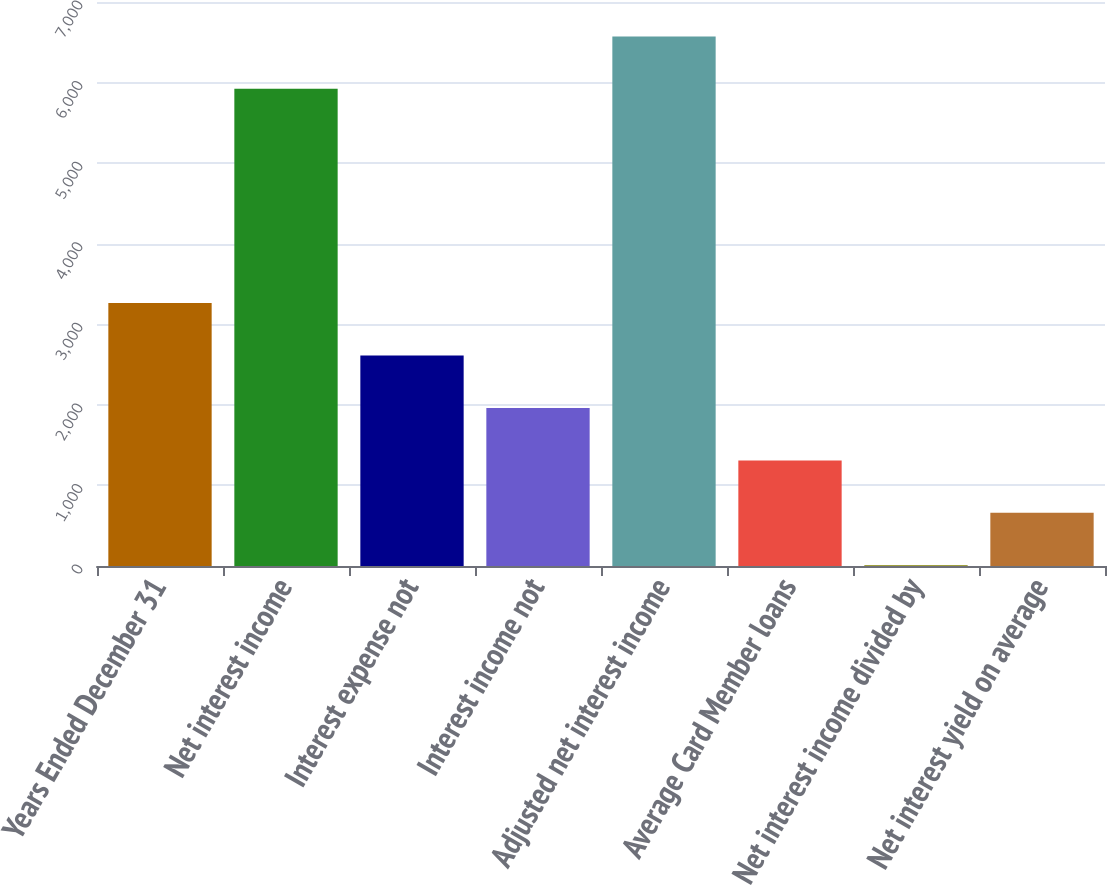<chart> <loc_0><loc_0><loc_500><loc_500><bar_chart><fcel>Years Ended December 31<fcel>Net interest income<fcel>Interest expense not<fcel>Interest income not<fcel>Adjusted net interest income<fcel>Average Card Member loans<fcel>Net interest income divided by<fcel>Net interest yield on average<nl><fcel>3262.8<fcel>5922<fcel>2611.96<fcel>1961.12<fcel>6572.84<fcel>1310.28<fcel>8.6<fcel>659.44<nl></chart> 